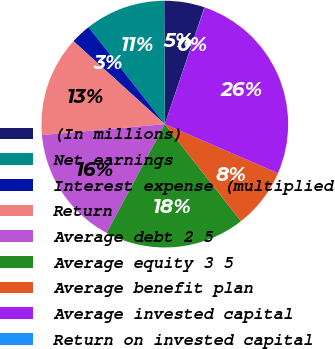Convert chart. <chart><loc_0><loc_0><loc_500><loc_500><pie_chart><fcel>(In millions)<fcel>Net earnings<fcel>Interest expense (multiplied<fcel>Return<fcel>Average debt 2 5<fcel>Average equity 3 5<fcel>Average benefit plan<fcel>Average invested capital<fcel>Return on invested capital<nl><fcel>5.28%<fcel>10.53%<fcel>2.66%<fcel>13.15%<fcel>15.77%<fcel>18.4%<fcel>7.9%<fcel>26.27%<fcel>0.03%<nl></chart> 